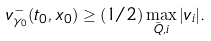<formula> <loc_0><loc_0><loc_500><loc_500>v _ { \gamma _ { 0 } } ^ { - } ( t _ { 0 } , x _ { 0 } ) \geq ( 1 / 2 ) \max _ { \bar { Q } , i } | v _ { i } | .</formula> 